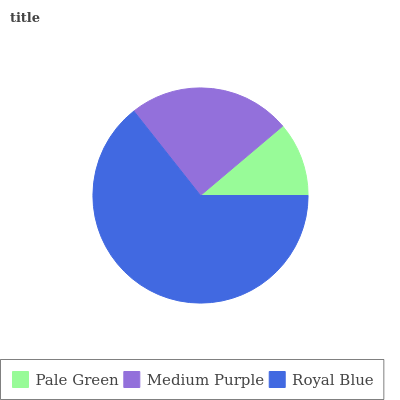Is Pale Green the minimum?
Answer yes or no. Yes. Is Royal Blue the maximum?
Answer yes or no. Yes. Is Medium Purple the minimum?
Answer yes or no. No. Is Medium Purple the maximum?
Answer yes or no. No. Is Medium Purple greater than Pale Green?
Answer yes or no. Yes. Is Pale Green less than Medium Purple?
Answer yes or no. Yes. Is Pale Green greater than Medium Purple?
Answer yes or no. No. Is Medium Purple less than Pale Green?
Answer yes or no. No. Is Medium Purple the high median?
Answer yes or no. Yes. Is Medium Purple the low median?
Answer yes or no. Yes. Is Pale Green the high median?
Answer yes or no. No. Is Royal Blue the low median?
Answer yes or no. No. 